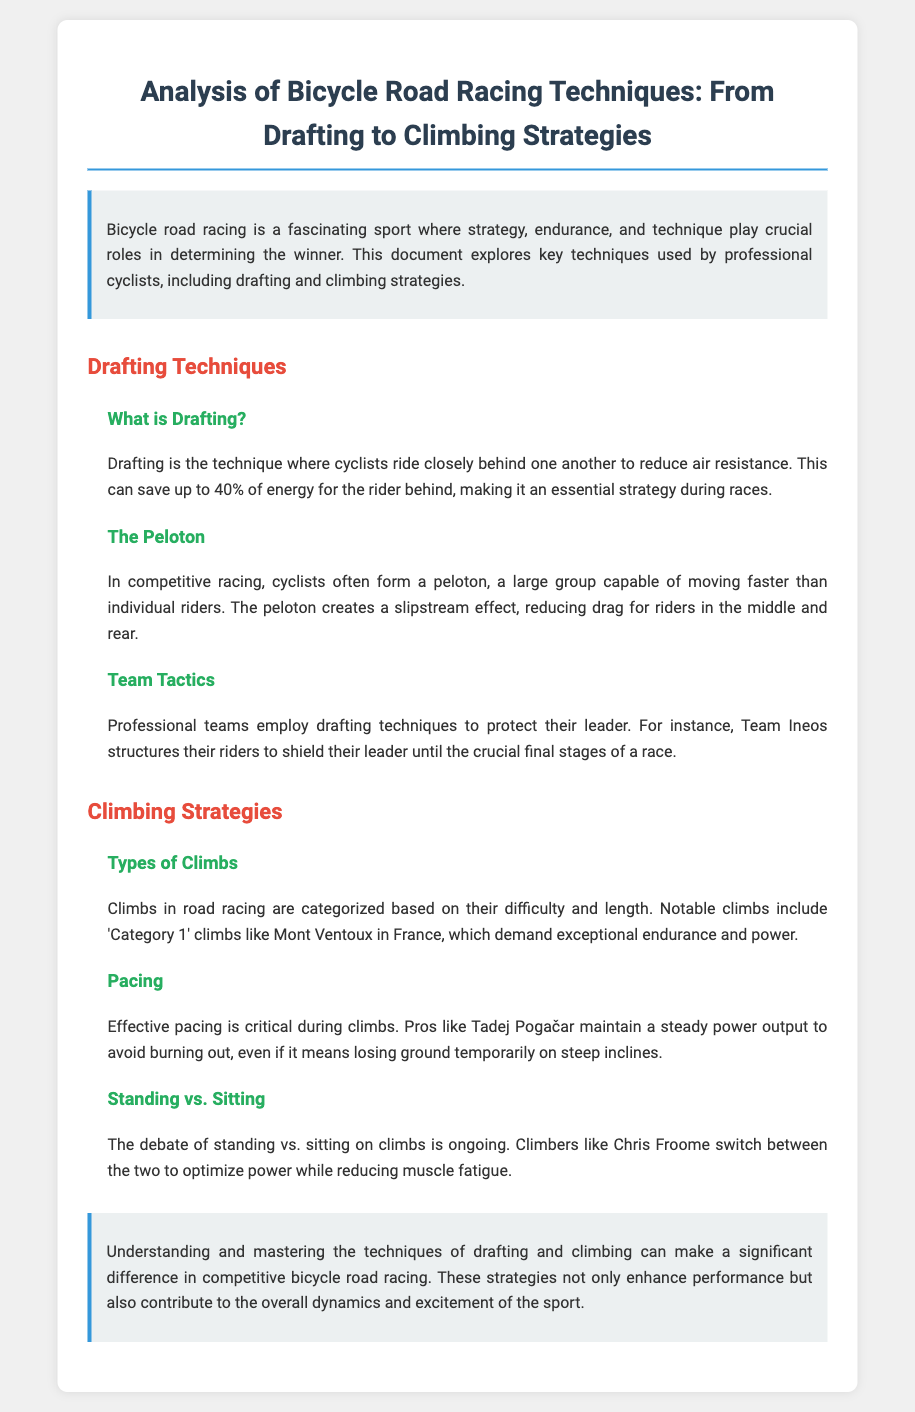What is drafting? Drafting is the technique where cyclists ride closely behind one another to reduce air resistance.
Answer: reduces air resistance What percentage of energy can be saved through drafting? The document states that drafting can save up to 40% of energy for the rider behind.
Answer: 40% What is a peloton? A peloton is a large group capable of moving faster than individual riders.
Answer: a large group Who is an example of a professional team that employs drafting techniques? The document mentions Team Ineos as an example of a professional team that uses drafting.
Answer: Team Ineos What is categorized as 'Category 1' climbs? Mont Ventoux in France is noted as a 'Category 1' climb in the document.
Answer: Mont Ventoux Who maintains a steady power output during climbs? The document highlights Tadej Pogačar as a pro who maintains a steady power output to avoid burning out.
Answer: Tadej Pogačar What is the ongoing debate during climbs mentioned? The debate mentioned is between standing and sitting on climbs.
Answer: standing vs. sitting What is the significance of understanding drafting and climbing techniques? The conclusion indicates that mastering these techniques makes a significant difference in racing.
Answer: a significant difference 